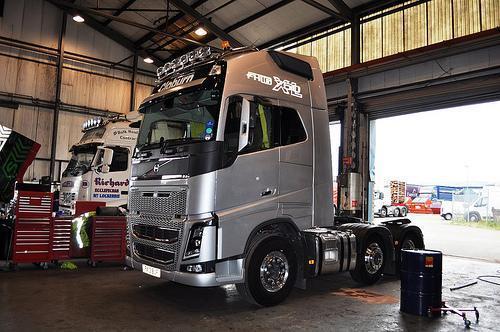How many trucks are in the picture?
Give a very brief answer. 2. 